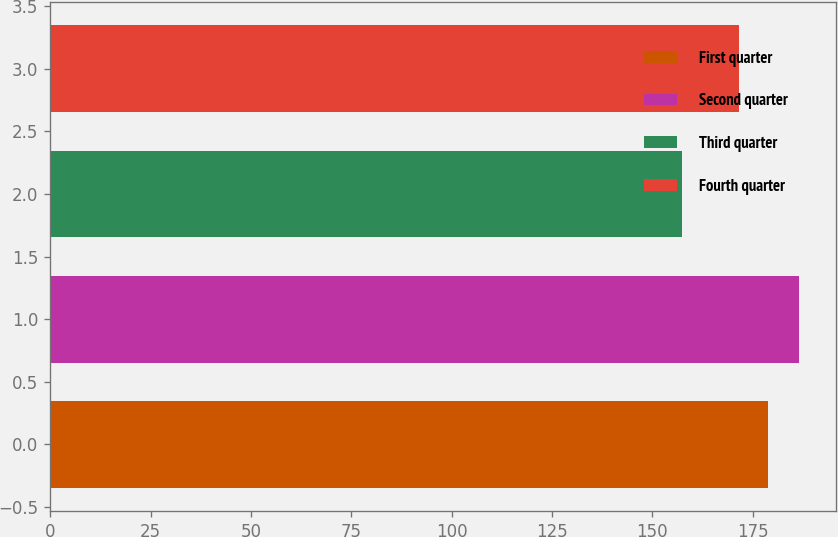<chart> <loc_0><loc_0><loc_500><loc_500><bar_chart><fcel>First quarter<fcel>Second quarter<fcel>Third quarter<fcel>Fourth quarter<nl><fcel>178.75<fcel>186.41<fcel>157.25<fcel>171.61<nl></chart> 